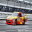What kind of safety mechanisms are typically integrated into a race car like the one shown in the image? Race cars like the one shown are built with multiple advanced safety mechanisms to protect the driver during high-speed impacts and crashes. Key safety features include a roll cage, which is a reinforced frame built into the body of the car to prevent the cabin from collapsing. Additionally, the seats are usually made of high-strength materials and are equipped with multi-point harness seatbelts that secure the driver firmly in place. There are also fire suppression systems designed to extinguish fires quickly in the event of a fuel line break or an engine fire. Moreover, the materials used in the bodywork are often fire-resistant, and energy-absorbing panels are installed to disperse impact forces more effectively. 